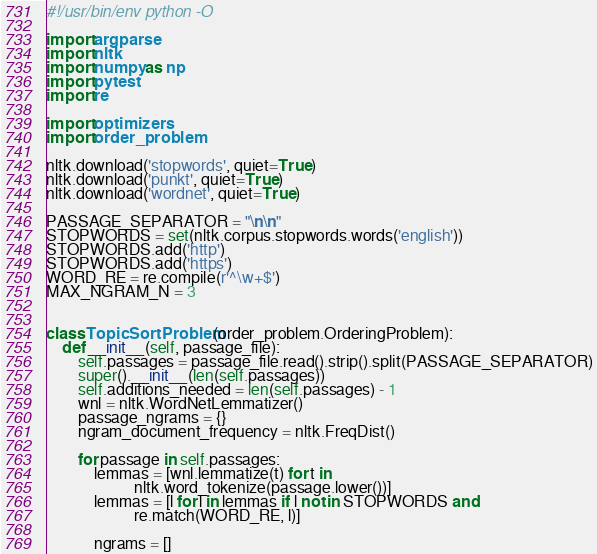Convert code to text. <code><loc_0><loc_0><loc_500><loc_500><_Python_>#!/usr/bin/env python -O

import argparse
import nltk
import numpy as np
import pytest
import re

import optimizers
import order_problem

nltk.download('stopwords', quiet=True)
nltk.download('punkt', quiet=True)
nltk.download('wordnet', quiet=True)

PASSAGE_SEPARATOR = "\n\n"
STOPWORDS = set(nltk.corpus.stopwords.words('english'))
STOPWORDS.add('http')
STOPWORDS.add('https')
WORD_RE = re.compile(r'^\w+$')
MAX_NGRAM_N = 3


class TopicSortProblem(order_problem.OrderingProblem):
    def __init__(self, passage_file):
        self.passages = passage_file.read().strip().split(PASSAGE_SEPARATOR)
        super().__init__(len(self.passages))
        self.additions_needed = len(self.passages) - 1
        wnl = nltk.WordNetLemmatizer()
        passage_ngrams = {}
        ngram_document_frequency = nltk.FreqDist()

        for passage in self.passages:
            lemmas = [wnl.lemmatize(t) for t in
                      nltk.word_tokenize(passage.lower())]
            lemmas = [l for l in lemmas if l not in STOPWORDS and
                      re.match(WORD_RE, l)]

            ngrams = []</code> 